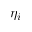<formula> <loc_0><loc_0><loc_500><loc_500>\eta _ { i }</formula> 